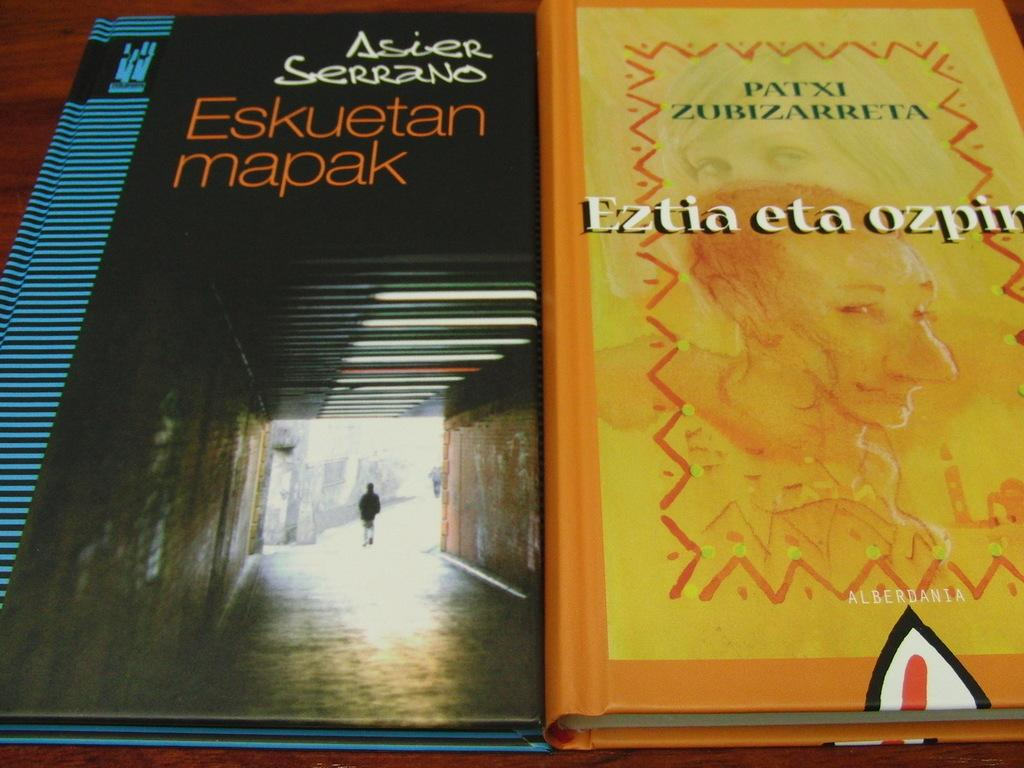<image>
Render a clear and concise summary of the photo. Eskuetan mapak and Eztia eta ozpin book by Patxi Zubizarreta. 